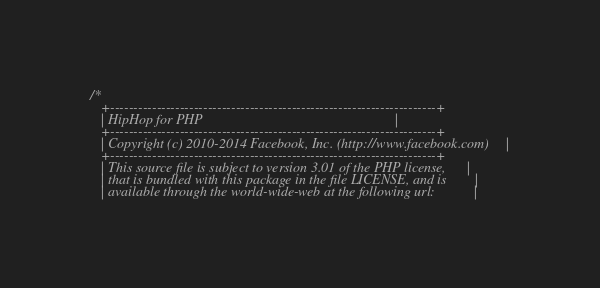Convert code to text. <code><loc_0><loc_0><loc_500><loc_500><_C_>/*
   +----------------------------------------------------------------------+
   | HipHop for PHP                                                       |
   +----------------------------------------------------------------------+
   | Copyright (c) 2010-2014 Facebook, Inc. (http://www.facebook.com)     |
   +----------------------------------------------------------------------+
   | This source file is subject to version 3.01 of the PHP license,      |
   | that is bundled with this package in the file LICENSE, and is        |
   | available through the world-wide-web at the following url:           |</code> 